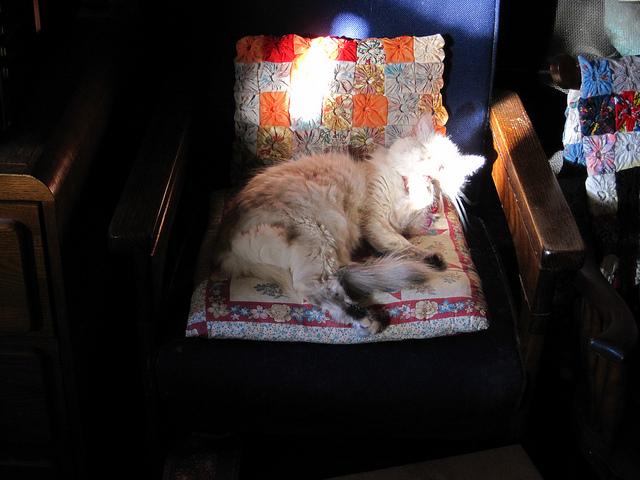What is the animal sleeping on?
Keep it brief. Blanket. What type of blanket is hanging to the right facing the chair?
Concise answer only. Quilt. What color is the chair?
Short answer required. Blue. 